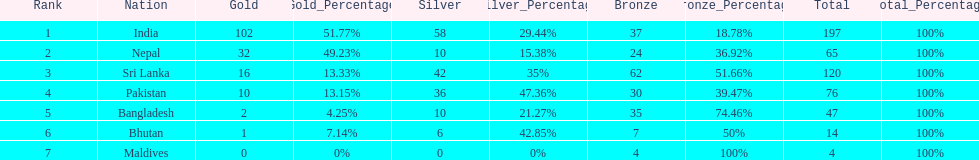What is the variation in the total quantity of medals between india and nepal? 132. 